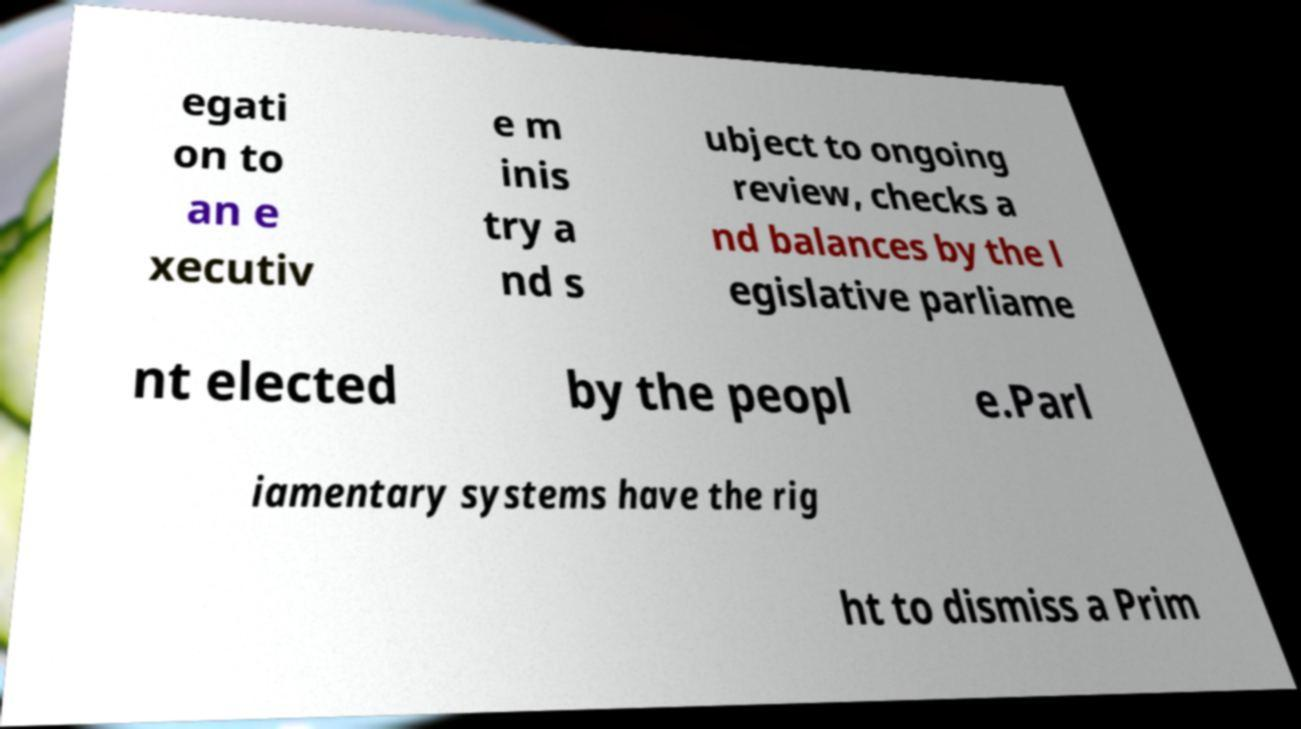Can you accurately transcribe the text from the provided image for me? egati on to an e xecutiv e m inis try a nd s ubject to ongoing review, checks a nd balances by the l egislative parliame nt elected by the peopl e.Parl iamentary systems have the rig ht to dismiss a Prim 